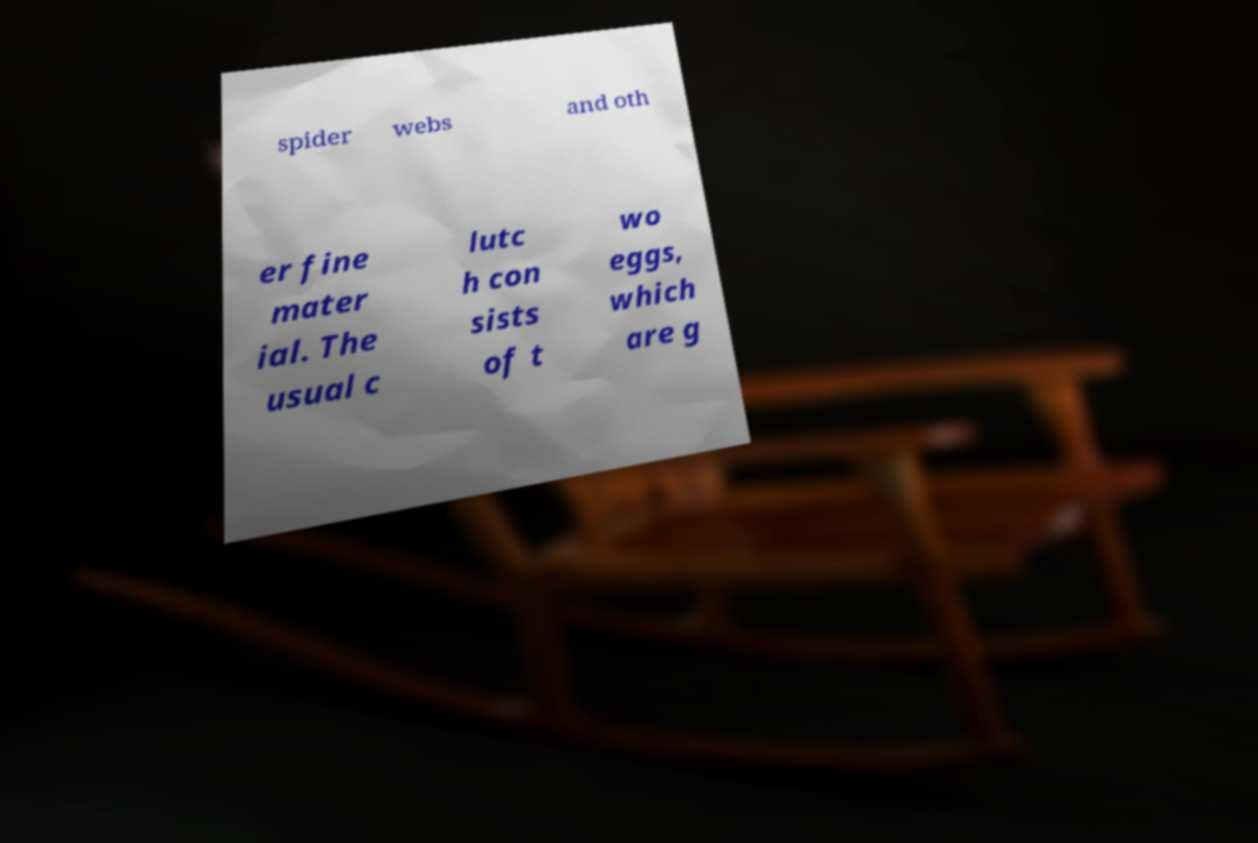What messages or text are displayed in this image? I need them in a readable, typed format. spider webs and oth er fine mater ial. The usual c lutc h con sists of t wo eggs, which are g 